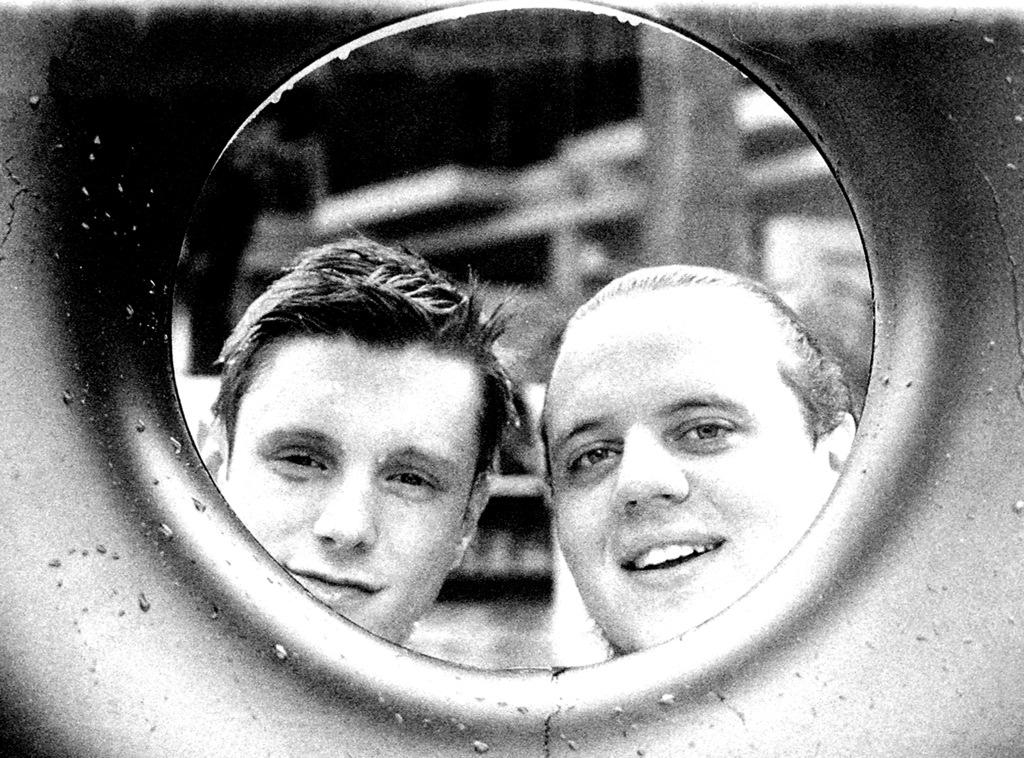What object in the image can reflect images? There is a mirror in the image that can reflect images. What can be seen in the mirror's reflection? The mirror reflects the faces of persons. How clear is the background in the mirror's reflection? The background in the mirror's reflection is blurry. How many times did the person fall while trying to adjust the angle of the mirror in the image? There is no information about a person falling or adjusting the angle of the mirror in the image. 